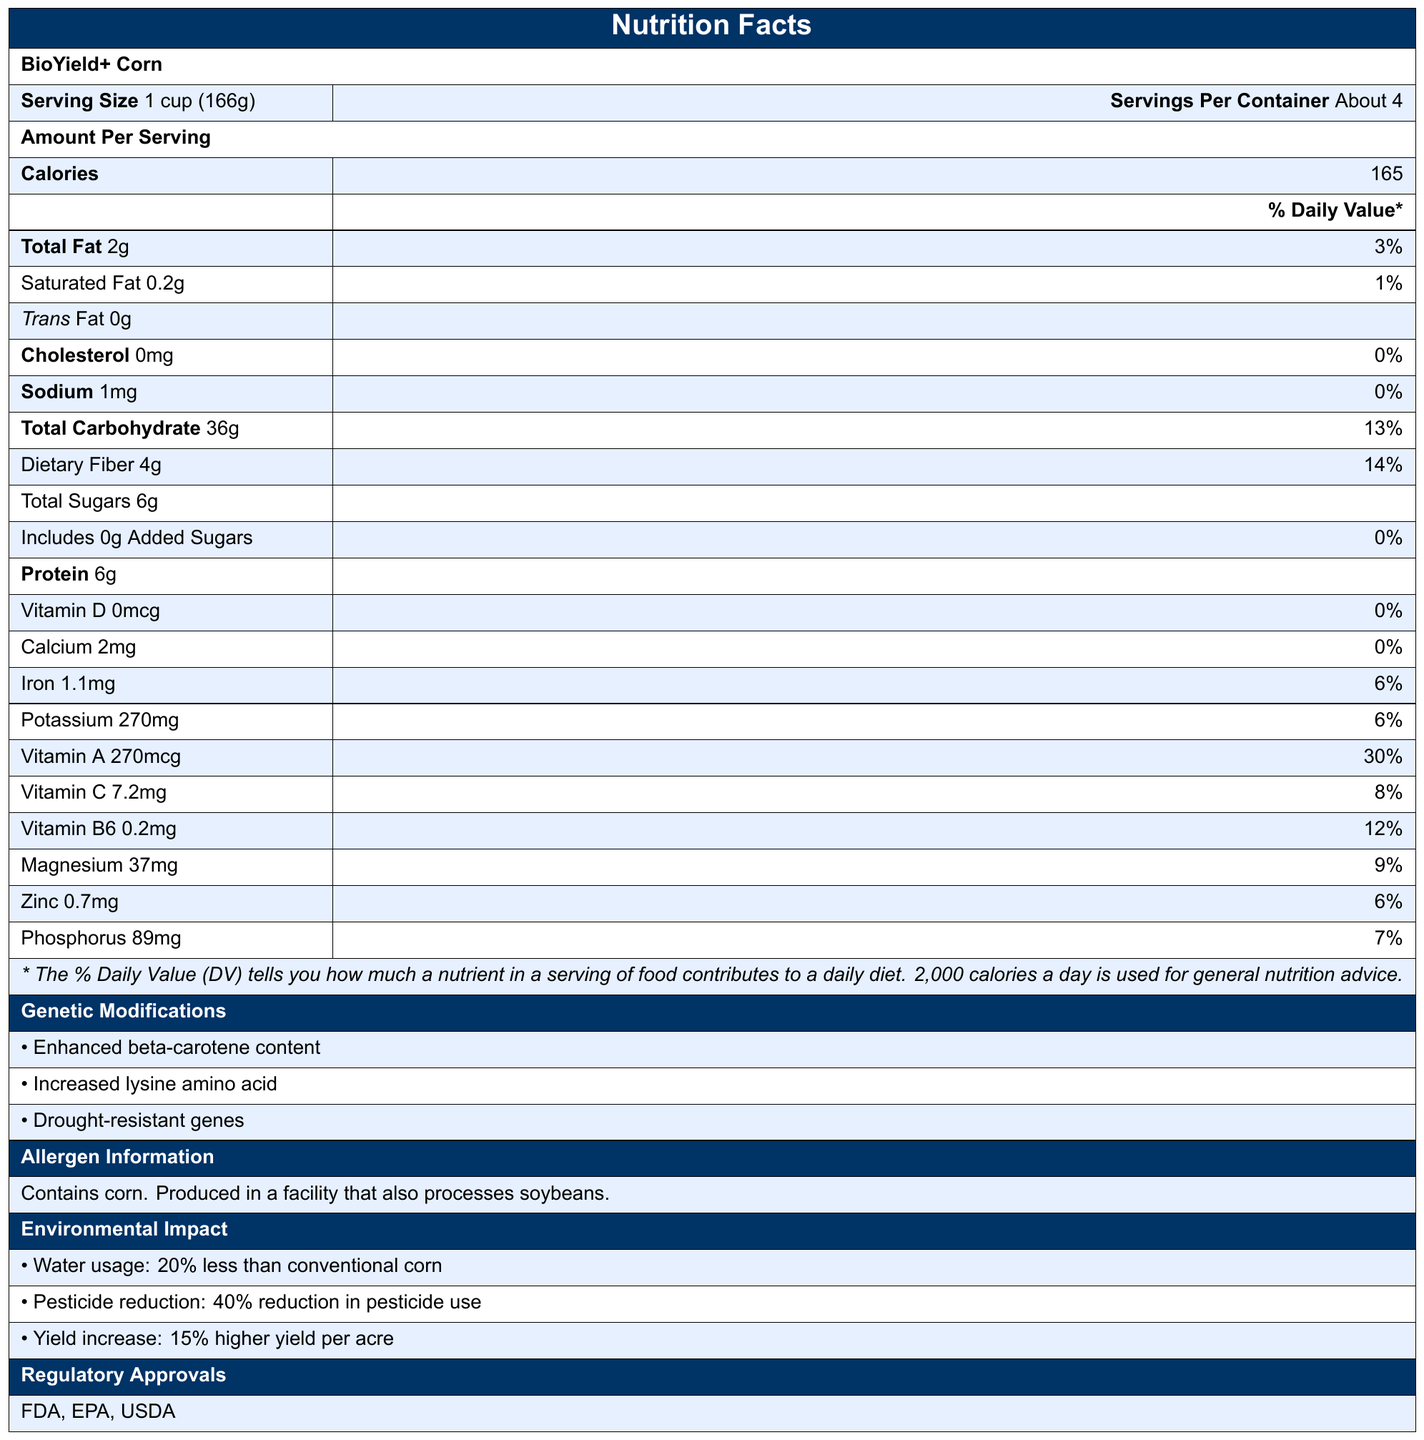what is the serving size for BioYield+ Corn? The serving size is explicitly mentioned as "1 cup (166g)" in the document.
Answer: 1 cup (166g) how many calories are there per serving of BioYield+ Corn? The document states that there are 165 calories per serving.
Answer: 165 what is the total carbohydrate content per serving? The document lists the total carbohydrate content as 36g per serving.
Answer: 36g how much dietary fiber does BioYield+ Corn contain? The dietary fiber amount is specified as 4g per serving.
Answer: 4g what genetic modifications have been made to BioYield+ Corn? The genetic modifications listed are enhanced beta-carotene content, increased lysine amino acid, and drought-resistant genes.
Answer: Enhanced beta-carotene content, Increased lysine amino acid, Drought-resistant genes what is the percentage daily value of Vitamin A in a serving? The percentage daily value for Vitamin A is given as 30%.
Answer: 30% how much sodium is in a serving of BioYield+ Corn? The sodium content per serving is listed as 1mg.
Answer: 1mg what is the protein content per serving? The protein amount per serving is 6g according to the document.
Answer: 6g which of the following nutritional aspects is provided in the highest daily percentage value? A. Iron B. Vitamin C C. Dietary Fiber D. Phosphorus Vitamin C’s daily value percentage is 8%, while the others are lower than this percentage.
Answer: B. Vitamin C what is the environmental benefit of BioYield+ Corn in terms of water usage? A. 15% less than conventional corn B. 20% less than conventional corn C. 25% less than conventional corn D. 30% less than conventional corn The document states that BioYield+ Corn uses 20% less water than conventional corn.
Answer: B. 20% less than conventional corn does BioYield+ Corn contain any added sugars? The document explicitly states that BioYield+ Corn contains 0g of added sugars.
Answer: No has BioYield+ Corn received regulatory approvals? The document lists FDA, EPA, and USDA as regulatory approvals for BioYield+ Corn.
Answer: Yes summarize the main benefits and features of BioYield+ Corn as provided in the document. The document provides detailed nutritional information, environmental impact, genetic modifications, regulatory approvals, and potential policy considerations for BioYield+ Corn.
Answer: BioYield+ Corn is a genetically modified crop with enhanced beta-carotene, increased lysine, and drought-resistance. It has lower water usage, reduced pesticide use, and higher yield. It provides essential nutrients and addresses vitamin A deficiency, supports sustainable agriculture, and could reduce agricultural subsidies. It is approved by FDA, EPA, and USDA. how many new agricultural technology jobs are projected to be created due to BioYield+ Corn? The document mentions a projected job creation of 5,000 new agricultural technology jobs.
Answer: 5000 what is the allergen information for BioYield+ Corn? The allergen information indicates that it contains corn and is produced in a facility that processes soybeans.
Answer: Contains corn. Produced in a facility that also processes soybeans. can you determine the total revenue generated by BioYield+ Corn from the document? The document does not provide any information regarding the total revenue generated by BioYield+ Corn.
Answer: Cannot be determined 